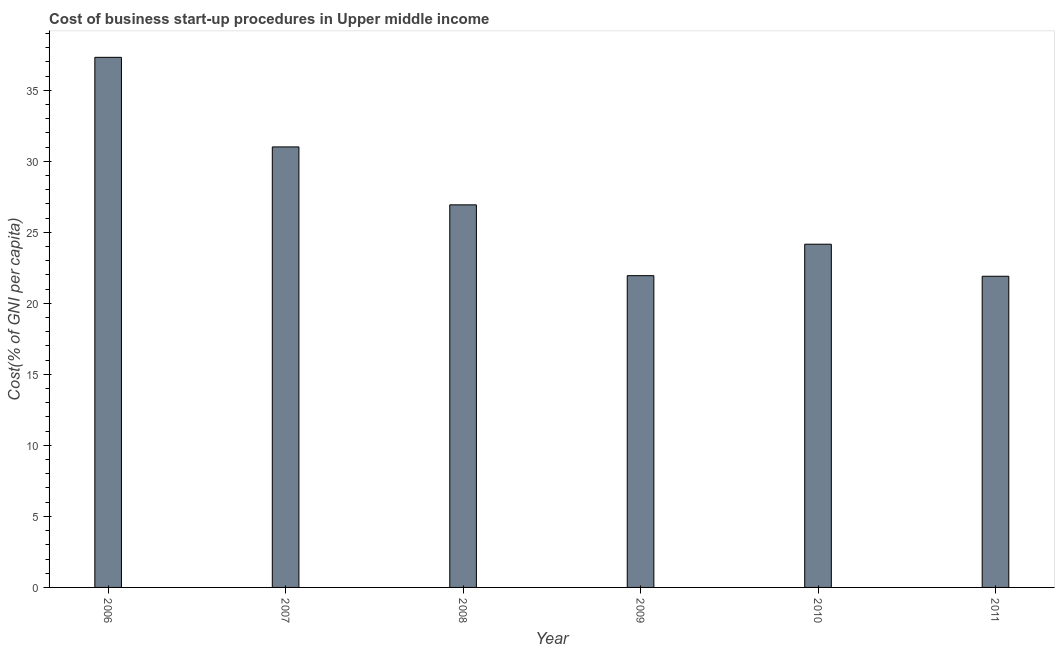Does the graph contain any zero values?
Offer a very short reply. No. What is the title of the graph?
Give a very brief answer. Cost of business start-up procedures in Upper middle income. What is the label or title of the Y-axis?
Keep it short and to the point. Cost(% of GNI per capita). What is the cost of business startup procedures in 2009?
Provide a short and direct response. 21.95. Across all years, what is the maximum cost of business startup procedures?
Ensure brevity in your answer.  37.32. Across all years, what is the minimum cost of business startup procedures?
Ensure brevity in your answer.  21.9. In which year was the cost of business startup procedures maximum?
Give a very brief answer. 2006. In which year was the cost of business startup procedures minimum?
Ensure brevity in your answer.  2011. What is the sum of the cost of business startup procedures?
Give a very brief answer. 163.27. What is the difference between the cost of business startup procedures in 2008 and 2011?
Offer a terse response. 5.03. What is the average cost of business startup procedures per year?
Keep it short and to the point. 27.21. What is the median cost of business startup procedures?
Give a very brief answer. 25.55. What is the ratio of the cost of business startup procedures in 2007 to that in 2010?
Provide a succinct answer. 1.28. What is the difference between the highest and the second highest cost of business startup procedures?
Provide a short and direct response. 6.31. What is the difference between the highest and the lowest cost of business startup procedures?
Provide a short and direct response. 15.41. What is the difference between two consecutive major ticks on the Y-axis?
Offer a very short reply. 5. What is the Cost(% of GNI per capita) in 2006?
Provide a succinct answer. 37.32. What is the Cost(% of GNI per capita) of 2007?
Your response must be concise. 31.01. What is the Cost(% of GNI per capita) in 2008?
Offer a very short reply. 26.93. What is the Cost(% of GNI per capita) of 2009?
Offer a terse response. 21.95. What is the Cost(% of GNI per capita) of 2010?
Ensure brevity in your answer.  24.16. What is the Cost(% of GNI per capita) of 2011?
Offer a terse response. 21.9. What is the difference between the Cost(% of GNI per capita) in 2006 and 2007?
Offer a very short reply. 6.31. What is the difference between the Cost(% of GNI per capita) in 2006 and 2008?
Keep it short and to the point. 10.38. What is the difference between the Cost(% of GNI per capita) in 2006 and 2009?
Offer a very short reply. 15.37. What is the difference between the Cost(% of GNI per capita) in 2006 and 2010?
Keep it short and to the point. 13.16. What is the difference between the Cost(% of GNI per capita) in 2006 and 2011?
Keep it short and to the point. 15.41. What is the difference between the Cost(% of GNI per capita) in 2007 and 2008?
Make the answer very short. 4.08. What is the difference between the Cost(% of GNI per capita) in 2007 and 2009?
Make the answer very short. 9.06. What is the difference between the Cost(% of GNI per capita) in 2007 and 2010?
Ensure brevity in your answer.  6.85. What is the difference between the Cost(% of GNI per capita) in 2007 and 2011?
Ensure brevity in your answer.  9.1. What is the difference between the Cost(% of GNI per capita) in 2008 and 2009?
Provide a succinct answer. 4.98. What is the difference between the Cost(% of GNI per capita) in 2008 and 2010?
Your answer should be very brief. 2.77. What is the difference between the Cost(% of GNI per capita) in 2008 and 2011?
Provide a succinct answer. 5.03. What is the difference between the Cost(% of GNI per capita) in 2009 and 2010?
Your answer should be compact. -2.21. What is the difference between the Cost(% of GNI per capita) in 2009 and 2011?
Provide a succinct answer. 0.04. What is the difference between the Cost(% of GNI per capita) in 2010 and 2011?
Provide a short and direct response. 2.26. What is the ratio of the Cost(% of GNI per capita) in 2006 to that in 2007?
Give a very brief answer. 1.2. What is the ratio of the Cost(% of GNI per capita) in 2006 to that in 2008?
Offer a very short reply. 1.39. What is the ratio of the Cost(% of GNI per capita) in 2006 to that in 2009?
Your answer should be compact. 1.7. What is the ratio of the Cost(% of GNI per capita) in 2006 to that in 2010?
Your answer should be very brief. 1.54. What is the ratio of the Cost(% of GNI per capita) in 2006 to that in 2011?
Offer a very short reply. 1.7. What is the ratio of the Cost(% of GNI per capita) in 2007 to that in 2008?
Your answer should be very brief. 1.15. What is the ratio of the Cost(% of GNI per capita) in 2007 to that in 2009?
Offer a very short reply. 1.41. What is the ratio of the Cost(% of GNI per capita) in 2007 to that in 2010?
Make the answer very short. 1.28. What is the ratio of the Cost(% of GNI per capita) in 2007 to that in 2011?
Provide a short and direct response. 1.42. What is the ratio of the Cost(% of GNI per capita) in 2008 to that in 2009?
Provide a succinct answer. 1.23. What is the ratio of the Cost(% of GNI per capita) in 2008 to that in 2010?
Provide a succinct answer. 1.11. What is the ratio of the Cost(% of GNI per capita) in 2008 to that in 2011?
Offer a very short reply. 1.23. What is the ratio of the Cost(% of GNI per capita) in 2009 to that in 2010?
Your answer should be compact. 0.91. What is the ratio of the Cost(% of GNI per capita) in 2010 to that in 2011?
Provide a short and direct response. 1.1. 